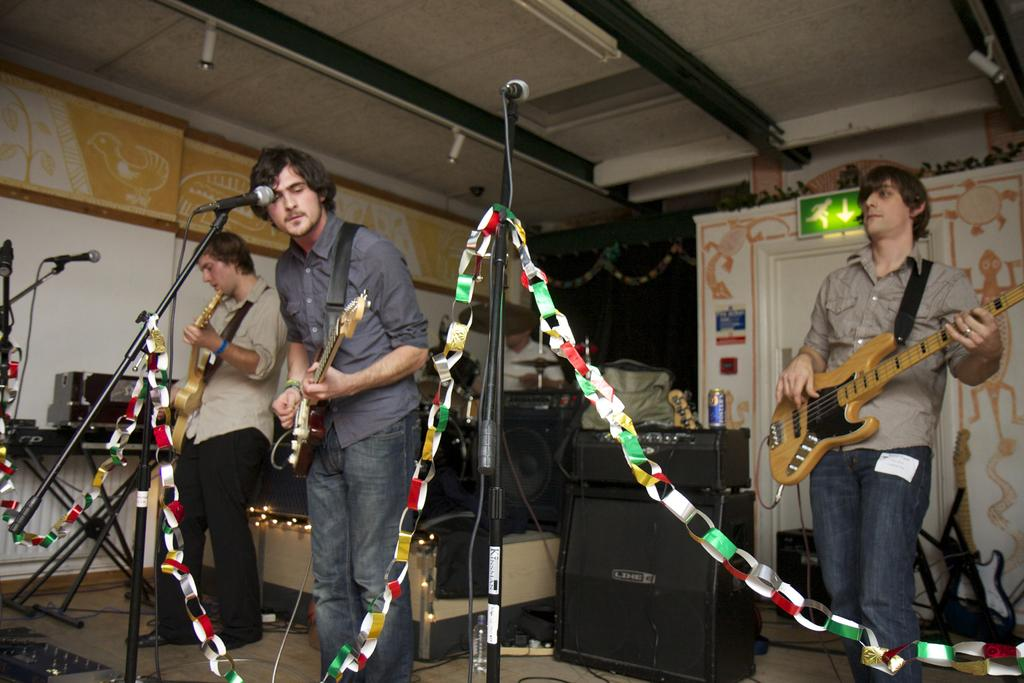How many people are in the image? There are three men in the image. What are the men doing in the image? The men are playing guitars. What object is in front of the men? There is a microphone in front of the men. Can you see any fangs on the men in the image? There are no fangs visible on the men in the image. Are the men's toes visible in the image? The men's toes are not visible in the image. 